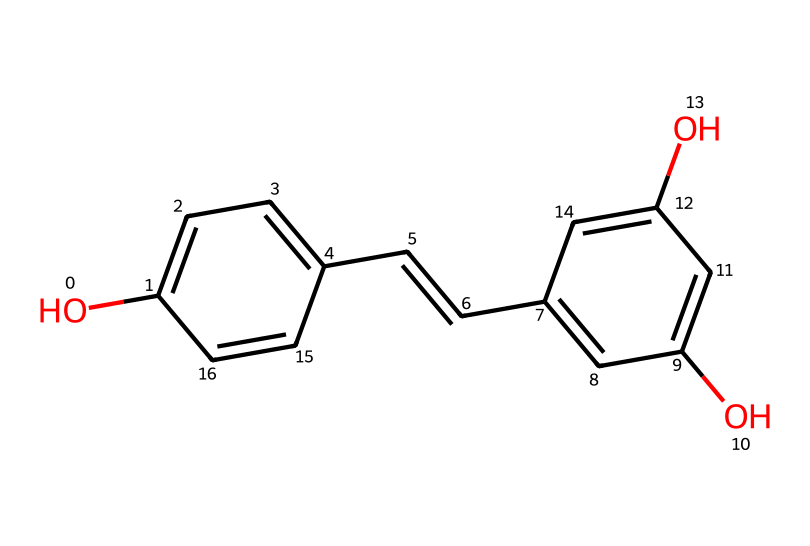What is the molecular formula of resveratrol? By observing the structure through the SMILES code, we can determine the molecular formula by counting the different types of atoms present. The structure consists of carbons (C), hydrogens (H), and oxygens (O). Counting them gives us C14H12O3.
Answer: C14H12O3 How many hydroxyl (-OH) groups are present in resveratrol? The hydroxyl groups are indicated by the 'O' connected to a 'c' in the structure. There are three of these - looking closely, we can find one on one benzene ring and two on the other.
Answer: 3 What type of functional groups are present in resveratrol? The presence of hydroxyl groups (-OH) identifies it as a phenolic compound. Additionally, there is an alkene functional group due to the C=C bond observed in the structure.
Answer: phenolic and alkene How many rings are present in the structure of resveratrol? The compound has two benzene rings, which can be identified by the 'c' notation in the SMILES code indicating aromatic carbon atoms.
Answer: 2 What is significant about the double bond in resveratrol? The double bond located in the alkene part of the structure contributes to its reactivity and is significant for biological activity, enhancing the antioxidant properties of resveratrol.
Answer: reactivity What classification does resveratrol belong to based on its structural features? Since resveratrol contains aromatic rings and hydroxyl groups, it is classified under phenolic compounds. The presence of these structural features is definitive for this classification.
Answer: phenolic compound 